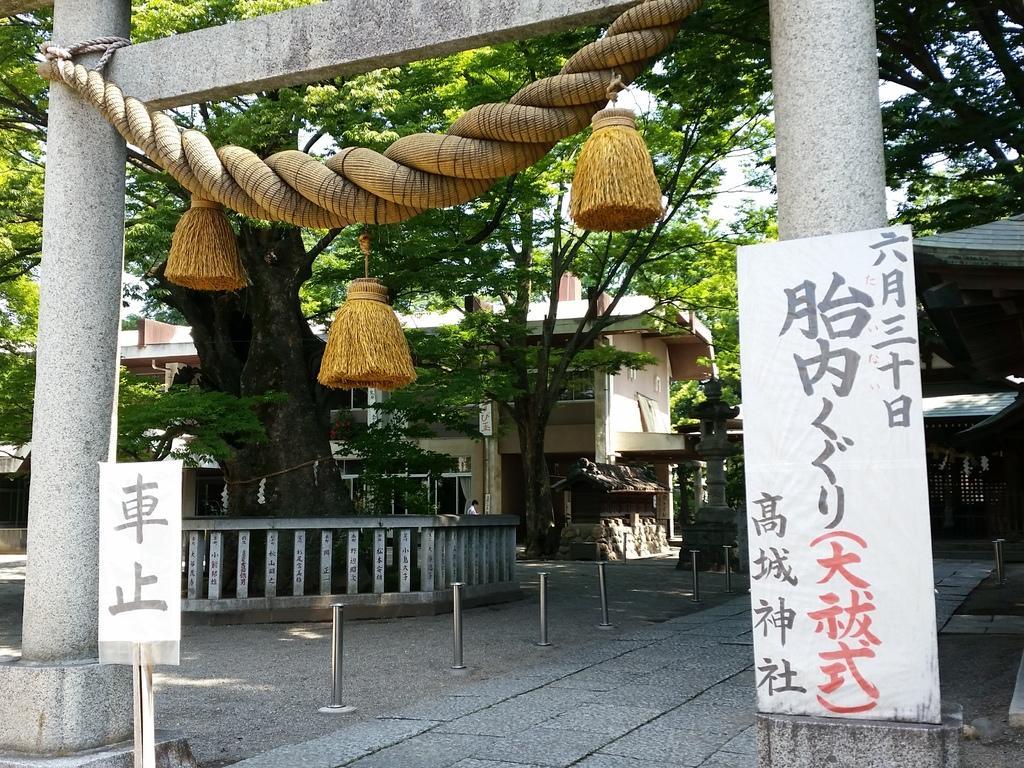In one or two sentences, can you explain what this image depicts? In this image I can see the rope to the arch. I can see the banners and the poles. In the background I can see the trees, buildings and the sky. 